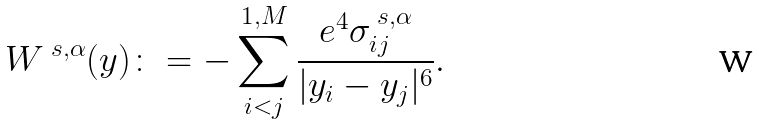<formula> <loc_0><loc_0><loc_500><loc_500>W ^ { \ s , \alpha } ( y ) \colon = - \sum _ { i < j } ^ { 1 , M } \frac { e ^ { 4 } \sigma ^ { \ s , \alpha } _ { i j } } { | y _ { i } - y _ { j } | ^ { 6 } } .</formula> 